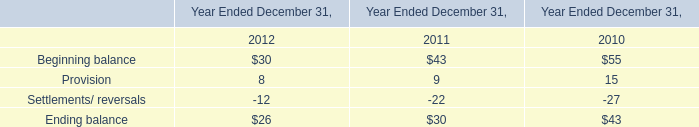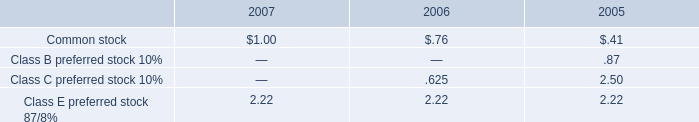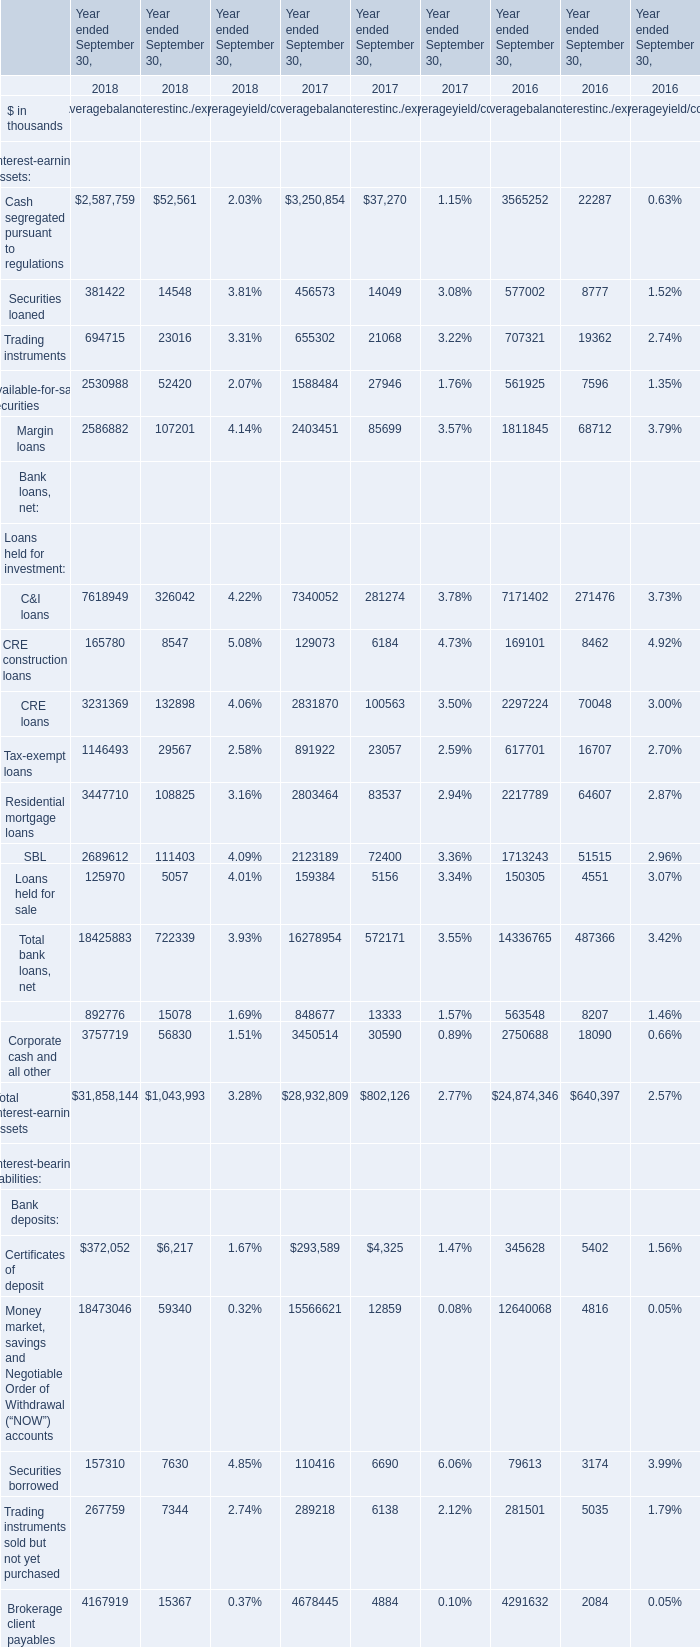What is the value of the Average balance for the Total interest-earning assets in 2017 ended September 30? (in thousand) 
Answer: 28932809. 